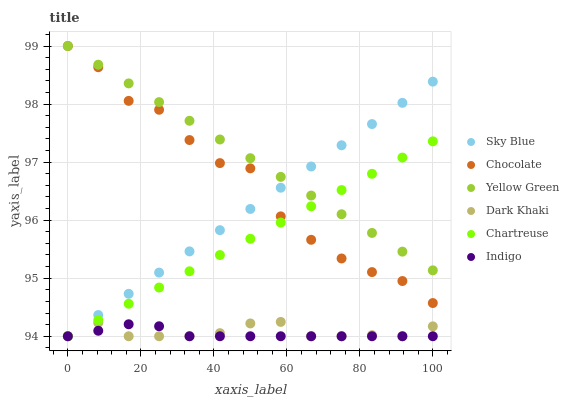Does Indigo have the minimum area under the curve?
Answer yes or no. Yes. Does Yellow Green have the maximum area under the curve?
Answer yes or no. Yes. Does Chocolate have the minimum area under the curve?
Answer yes or no. No. Does Chocolate have the maximum area under the curve?
Answer yes or no. No. Is Yellow Green the smoothest?
Answer yes or no. Yes. Is Chocolate the roughest?
Answer yes or no. Yes. Is Chocolate the smoothest?
Answer yes or no. No. Is Yellow Green the roughest?
Answer yes or no. No. Does Indigo have the lowest value?
Answer yes or no. Yes. Does Chocolate have the lowest value?
Answer yes or no. No. Does Chocolate have the highest value?
Answer yes or no. Yes. Does Dark Khaki have the highest value?
Answer yes or no. No. Is Dark Khaki less than Yellow Green?
Answer yes or no. Yes. Is Yellow Green greater than Indigo?
Answer yes or no. Yes. Does Chartreuse intersect Dark Khaki?
Answer yes or no. Yes. Is Chartreuse less than Dark Khaki?
Answer yes or no. No. Is Chartreuse greater than Dark Khaki?
Answer yes or no. No. Does Dark Khaki intersect Yellow Green?
Answer yes or no. No. 